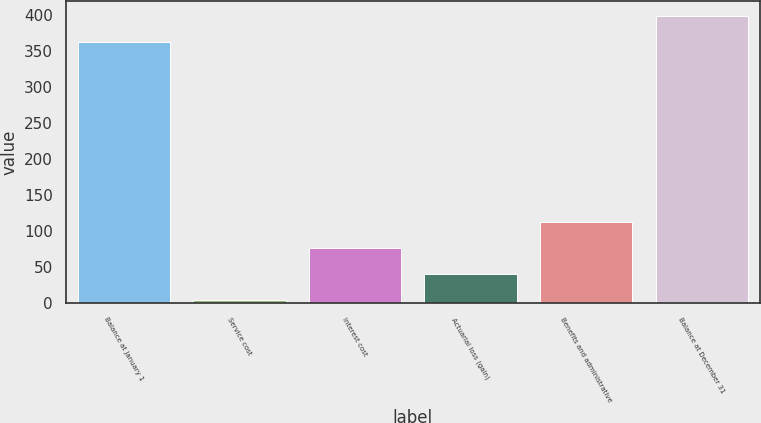Convert chart to OTSL. <chart><loc_0><loc_0><loc_500><loc_500><bar_chart><fcel>Balance at January 1<fcel>Service cost<fcel>Interest cost<fcel>Actuarial loss (gain)<fcel>Benefits and administrative<fcel>Balance at December 31<nl><fcel>363.1<fcel>4.9<fcel>77.22<fcel>41.06<fcel>113.38<fcel>399.26<nl></chart> 